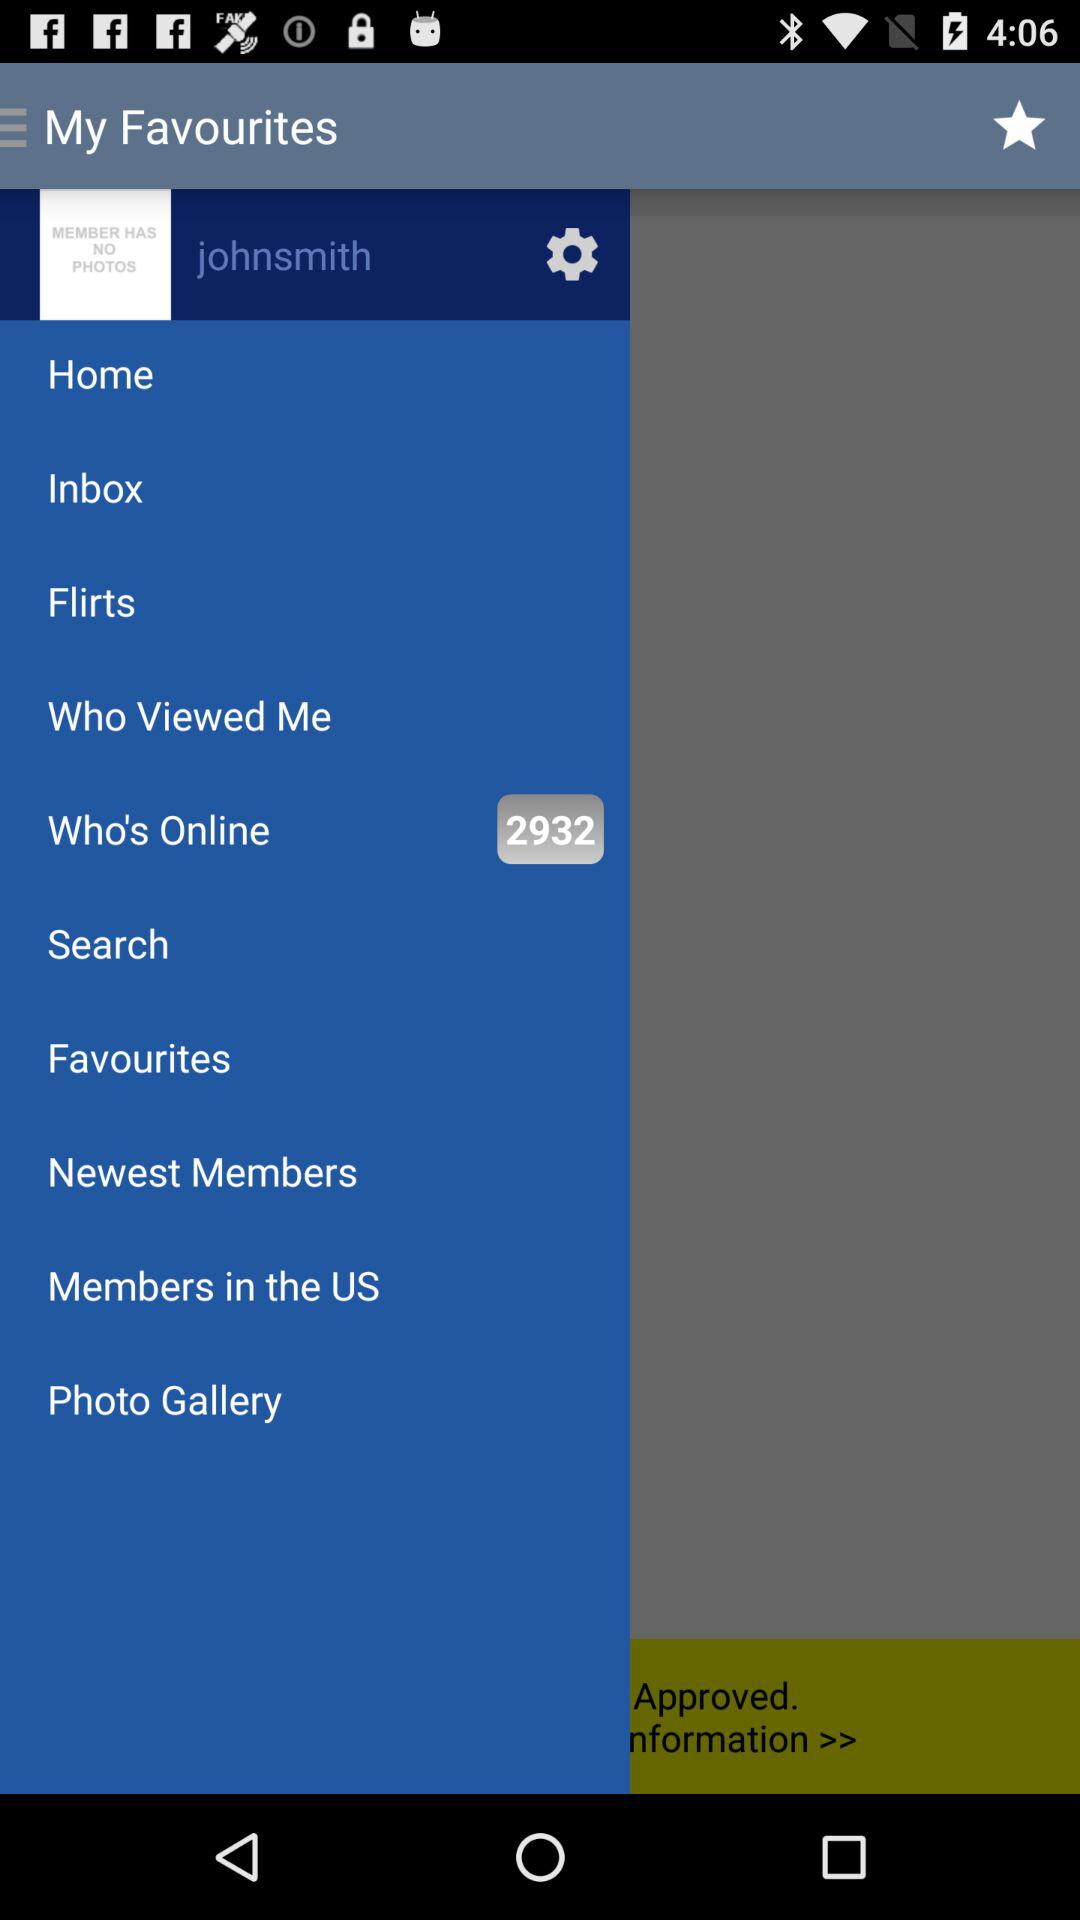What is the mentioned username? The mentioned username is "johnsmith". 